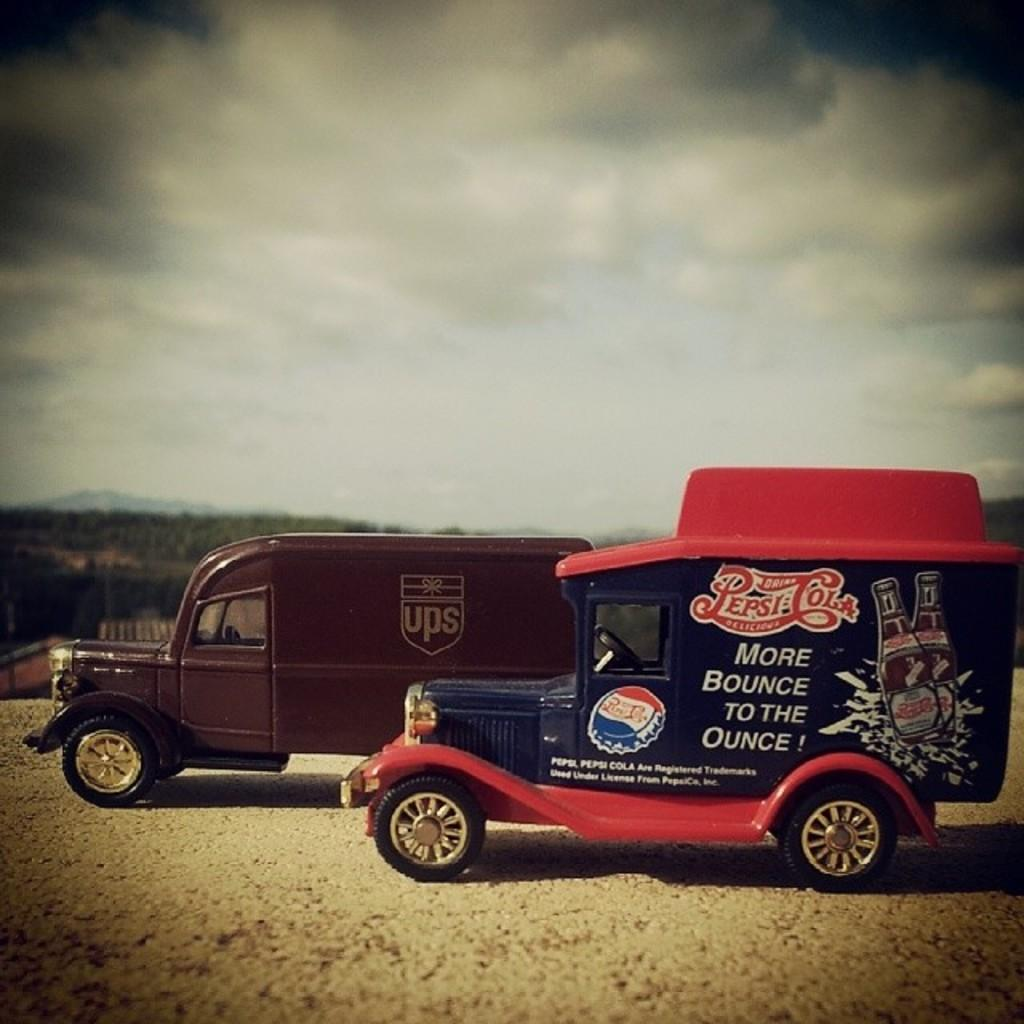What types of objects can be seen in the image? There are vehicles in the image. What kind of vegetation is present in the image? There are trees with green color in the image. What colors can be seen in the sky in the background? The sky in the background has a combination of white and blue colors. What role does the sister play in the image? There is no mention of a sister in the image, so it is not possible to determine her role. 